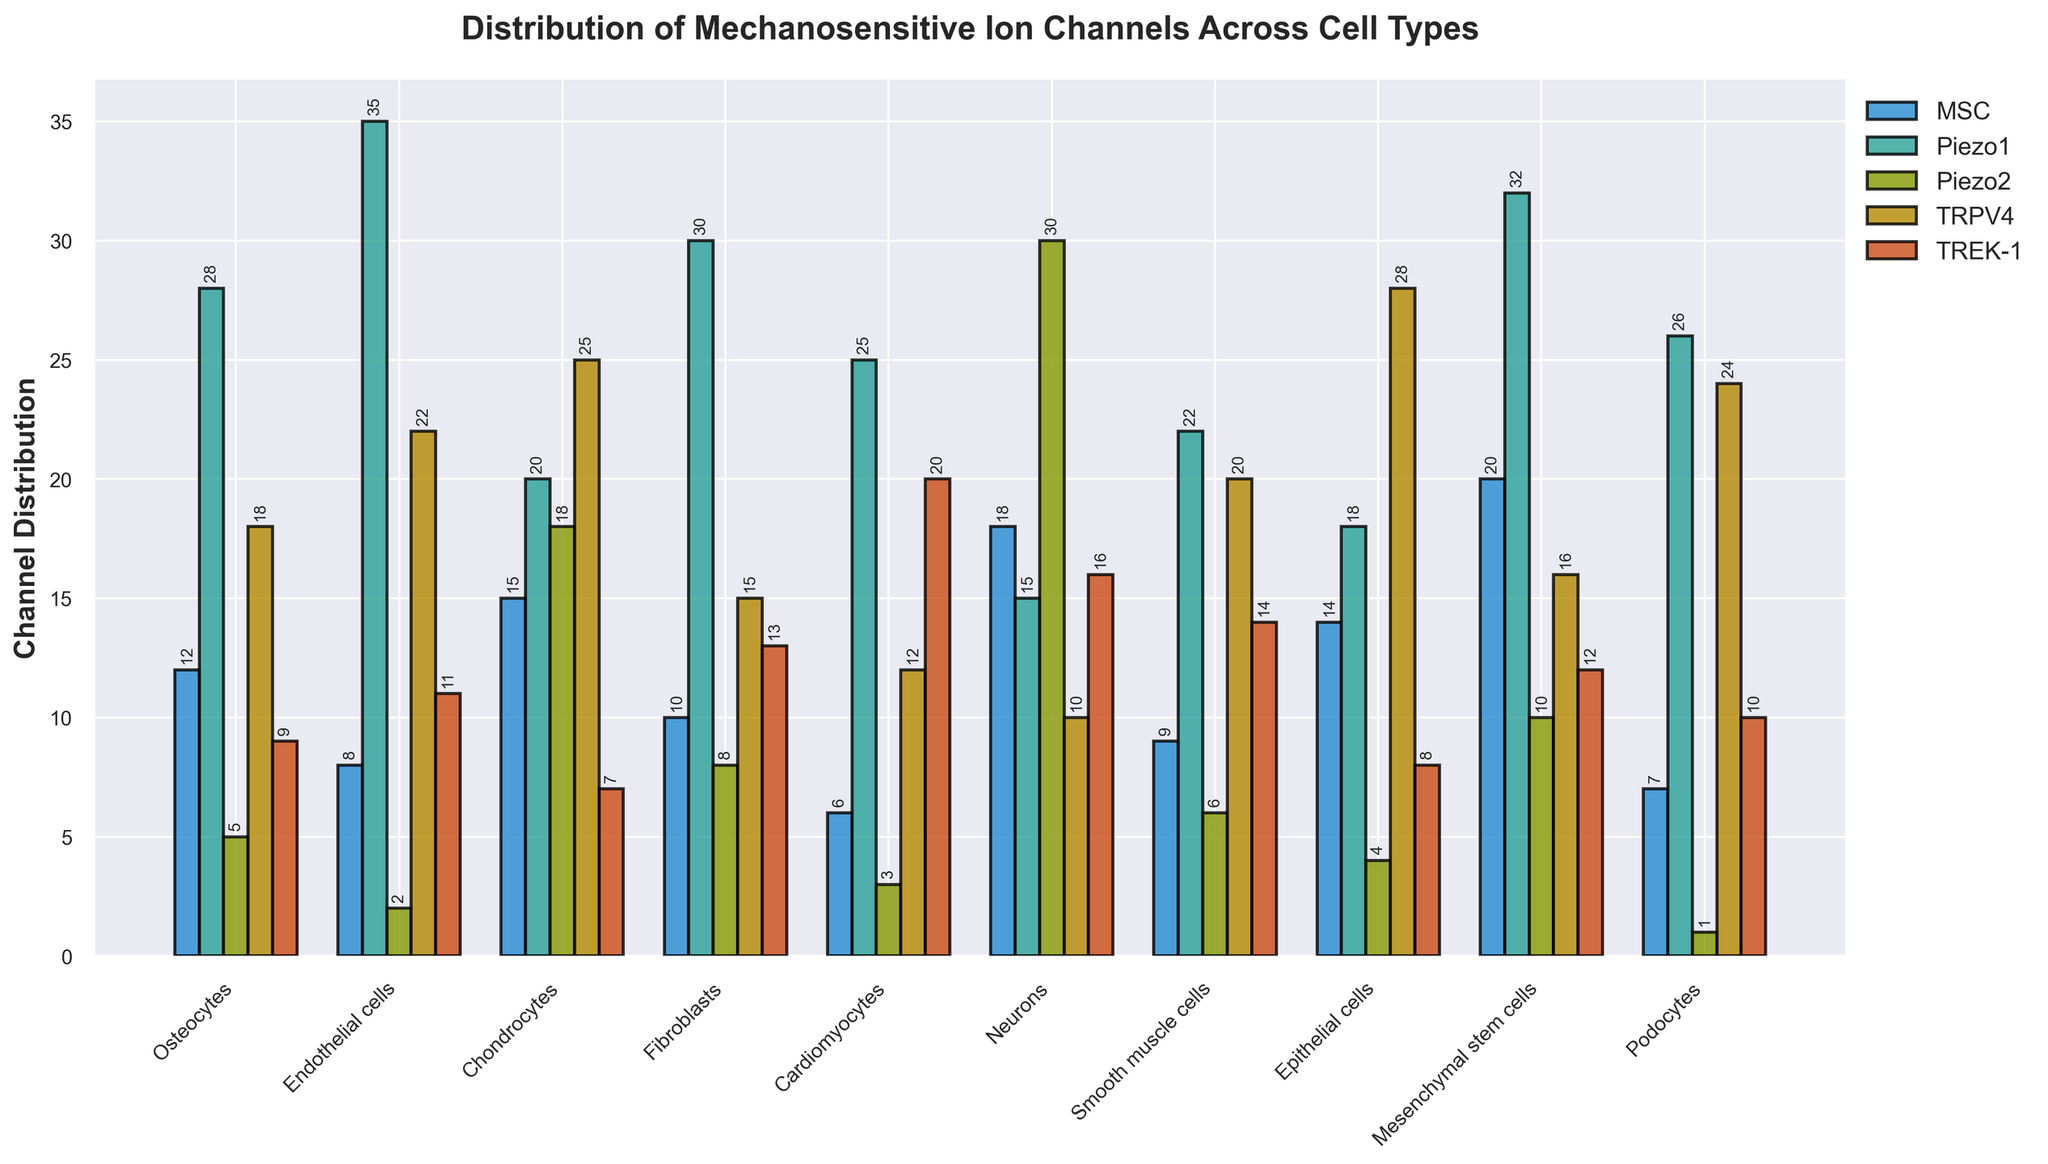Which cell type has the highest number of Piezo1 channels? The bars representing Piezo1 channels are filled with second color from left to right. Among all cell types, the bar for Endothelial cells is the tallest for Piezo1 channels.
Answer: Endothelial cells How many Piezo2 channels are there in Neurons compared to Cardiomyocytes? The Piezo2 channels for Neurons are represented by the third bar set from the left, and for Cardiomyocytes by the same colors two positions to the right. Neurons have 30 channels, whereas Cardiomyocytes have 3 channels.
Answer: 27 more in Neurons What is the total number of MSC channels across all cell types? Add the values of the MSC channels for all cell types: 12 (Osteocytes) + 8 (Endothelial cells) + 15 (Chondrocytes) + 10 (Fibroblasts) + 6 (Cardiomyocytes) + 18 (Neurons) + 9 (Smooth muscle cells) + 14 (Epithelial cells) + 20 (Mesenchymal stem cells) + 7 (Podocytes). Total sum is: 12+8+15+10+6+18+9+14+20+7 = 119
Answer: 119 Among the TRPV4 channels, which cell type has the lowest count and how many? The TRPV4 channels are the fourth set of bars from the left. The shortest bar among these is for Neurons. Neurons have 10 TRPV4 channels.
Answer: Neurons, 10 What is the average number of TREK-1 channels per cell type? Add the values of TREK-1 channels and then divide by the number of cell types (10): (9+11+7+13+20+16+14+8+12+10)/10 = 120/10 = 12
Answer: 12 Compare the total number of mechanosensitive channels in Chondrocytes and Neurons. Add the values for each channel in Chondrocytes: 15 (MSC) + 20 (Piezo1) + 18 (Piezo2) + 25 (TRPV4) + 7 (TREK-1) = 85. For Neurons: 18 (MSC) + 15 (Piezo1) + 30 (Piezo2) + 10 (TRPV4) + 16 (TREK-1) = 89.
Answer: 4 more in Neurons Which cell type has exactly 26 Piezo1 channels? Excluding other channels, focus on Piezo1 only, the bar with 26 belongs to Podocytes.
Answer: Podocytes What is the difference in TRPV4 channel count between Epithelial cells and Fibroblasts? Epithelial cells have 28 TRPV4 channels, while Fibroblasts have 15. The difference is 28 - 15 = 13.
Answer: 13 Which cell types have more MSC than TREK-1 channels? Compare the MSC and TREK-1 channels in each cell type: Osteocytes (12 vs 9), Fibroblasts (10 vs 13), Neurons (18 vs 16), Smooth muscle cells (9 vs 14), Epithelial cells (14 vs 8), Podocytes (7 vs 10). The ones with more MSC than TREK-1 are Osteocytes, Neurons, and Epithelial cells.
Answer: Osteocytes, Neurons, Epithelial cells 